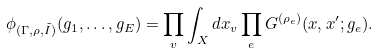<formula> <loc_0><loc_0><loc_500><loc_500>\phi _ { ( \Gamma , \rho , \tilde { I } ) } ( g _ { 1 } , \dots , g _ { E } ) = \prod _ { v } \int _ { X } d x _ { v } \prod _ { e } G ^ { ( \rho _ { e } ) } ( x , x ^ { \prime } ; g _ { e } ) .</formula> 